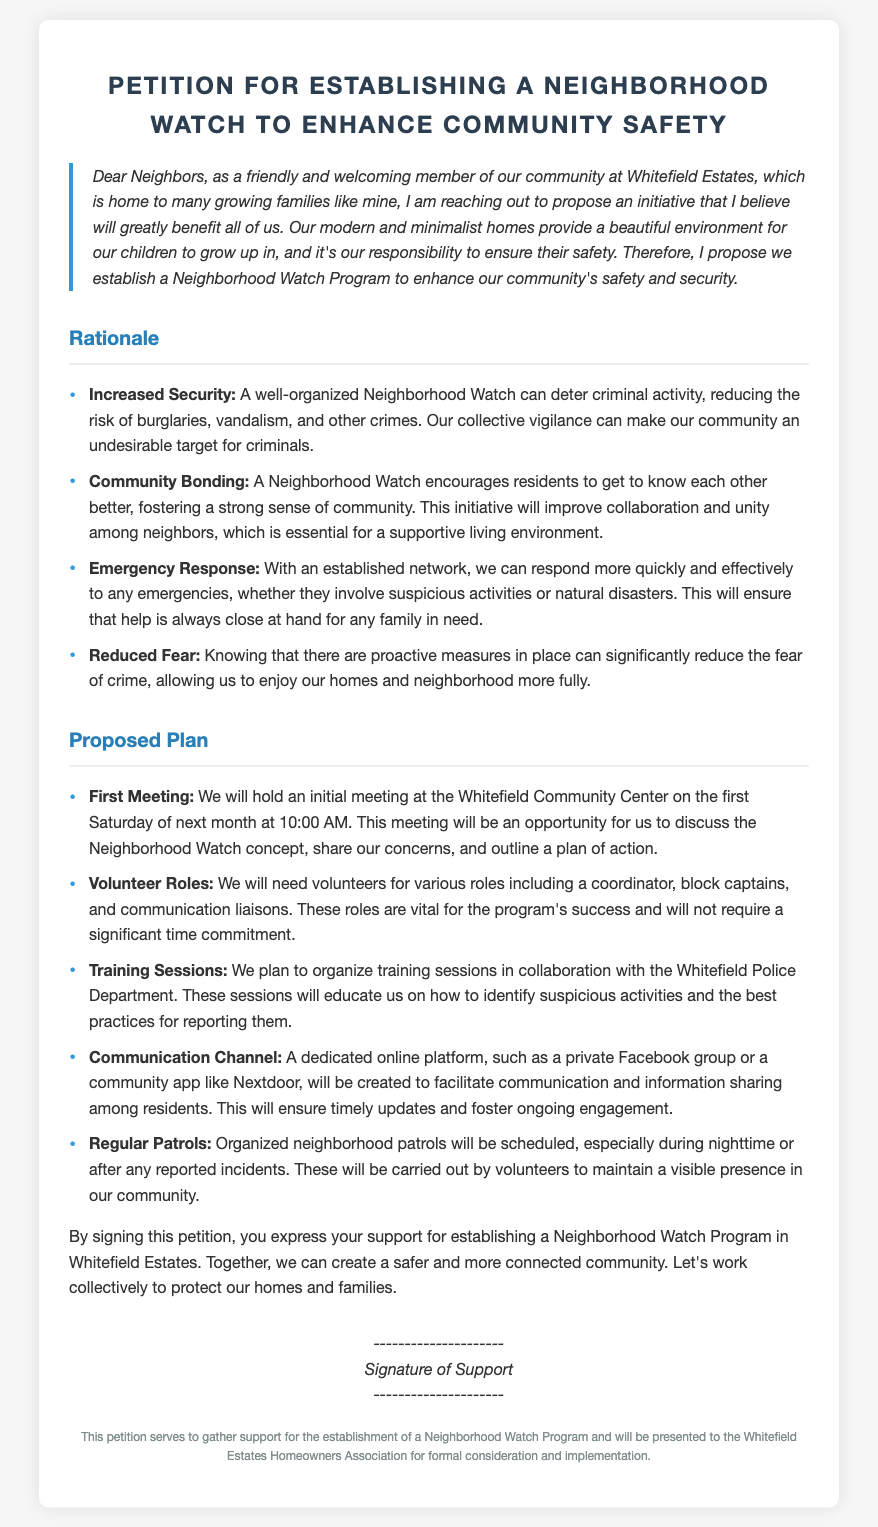What is the title of the petition? The title of the petition is prominently displayed at the top of the document.
Answer: Petition for Establishing a Neighborhood Watch to Enhance Community Safety What date is the first meeting scheduled for? The document states that the first meeting will be held on the first Saturday of next month, implying a specific date based on the current month.
Answer: First Saturday of next month What location is the first meeting set to take place? The location for the first meeting is mentioned in the Proposed Plan section of the document.
Answer: Whitefield Community Center What is one reason given for establishing a Neighborhood Watch? The document lists reasons for the petition's proposal, highlighting community benefits.
Answer: Increased Security What role is specifically mentioned as needing volunteers? The document outlines different roles needed for the Neighborhood Watch program, mentioning specific volunteer positions.
Answer: Coordinator How will communication be facilitated among residents? The document explains the method for maintaining communication within the community regarding the Neighborhood Watch.
Answer: Online platform What will be organized in collaboration with the Whitefield Police Department? There is a specific mention of the kind of sessions to be facilitated with the police for community education.
Answer: Training Sessions What is the purpose of signing this petition? The document clarifies the goal of collecting signatures and the significance of support for the initiative.
Answer: Express support for establishing a Neighborhood Watch Program What will regularly scheduled patrols help maintain? The document mentions a specific benefit of having organized patrols in the neighborhood.
Answer: Visible presence in our community 